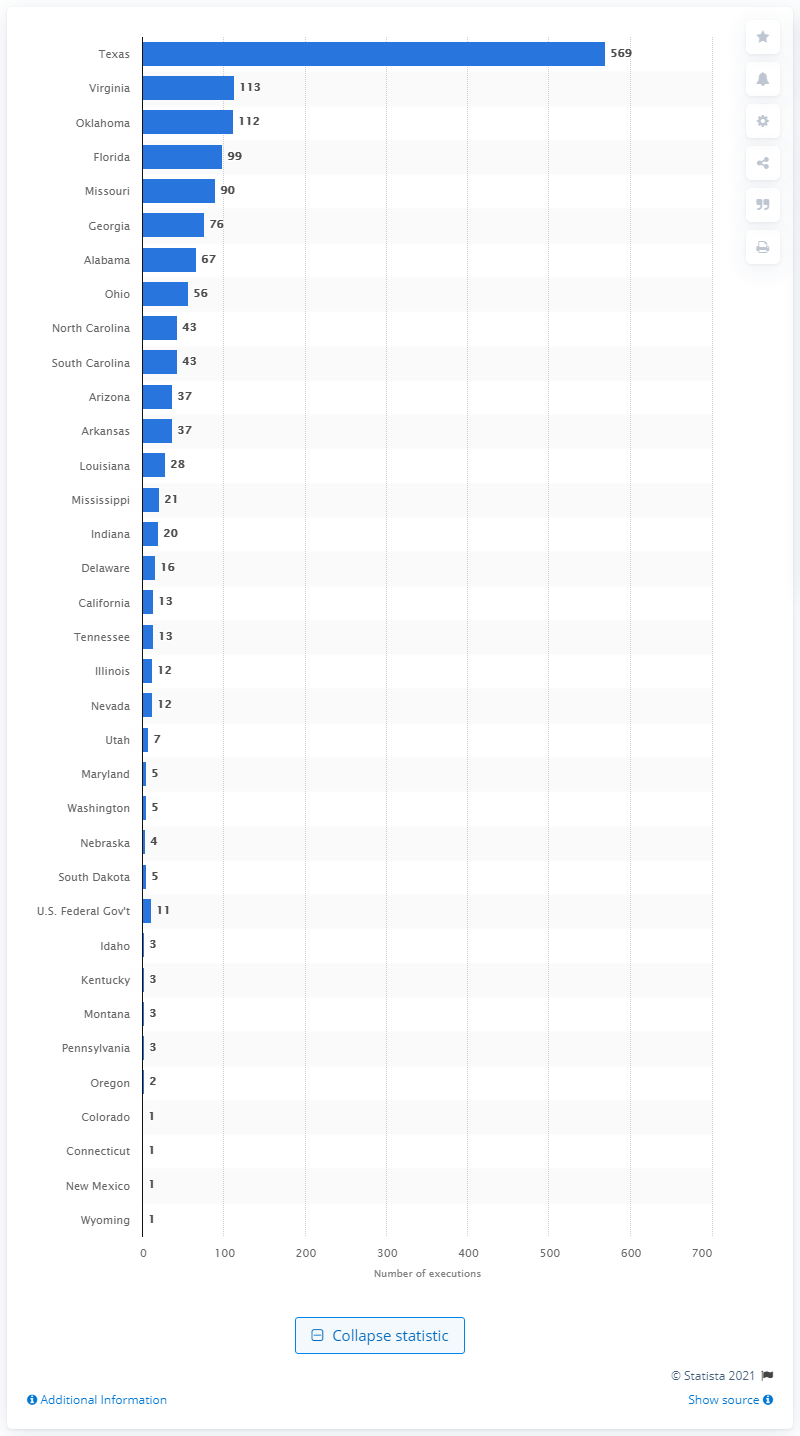Highlight a few significant elements in this photo. As of November 23, 2020, there were 569 people who had been executed in the state of Texas. 